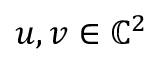<formula> <loc_0><loc_0><loc_500><loc_500>u , v \in \mathbb { C } ^ { 2 }</formula> 